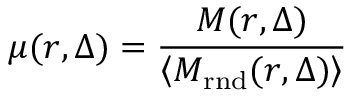Convert formula to latex. <formula><loc_0><loc_0><loc_500><loc_500>\mu ( r , \Delta ) = \frac { M ( r , \Delta ) } { \left \langle M _ { r n d } ( r , \Delta ) \right \rangle }</formula> 